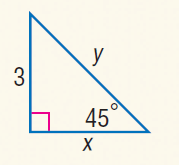Answer the mathemtical geometry problem and directly provide the correct option letter.
Question: Find x.
Choices: A: 3 B: 4 C: 5 D: 3 \sqrt { 3 } A 